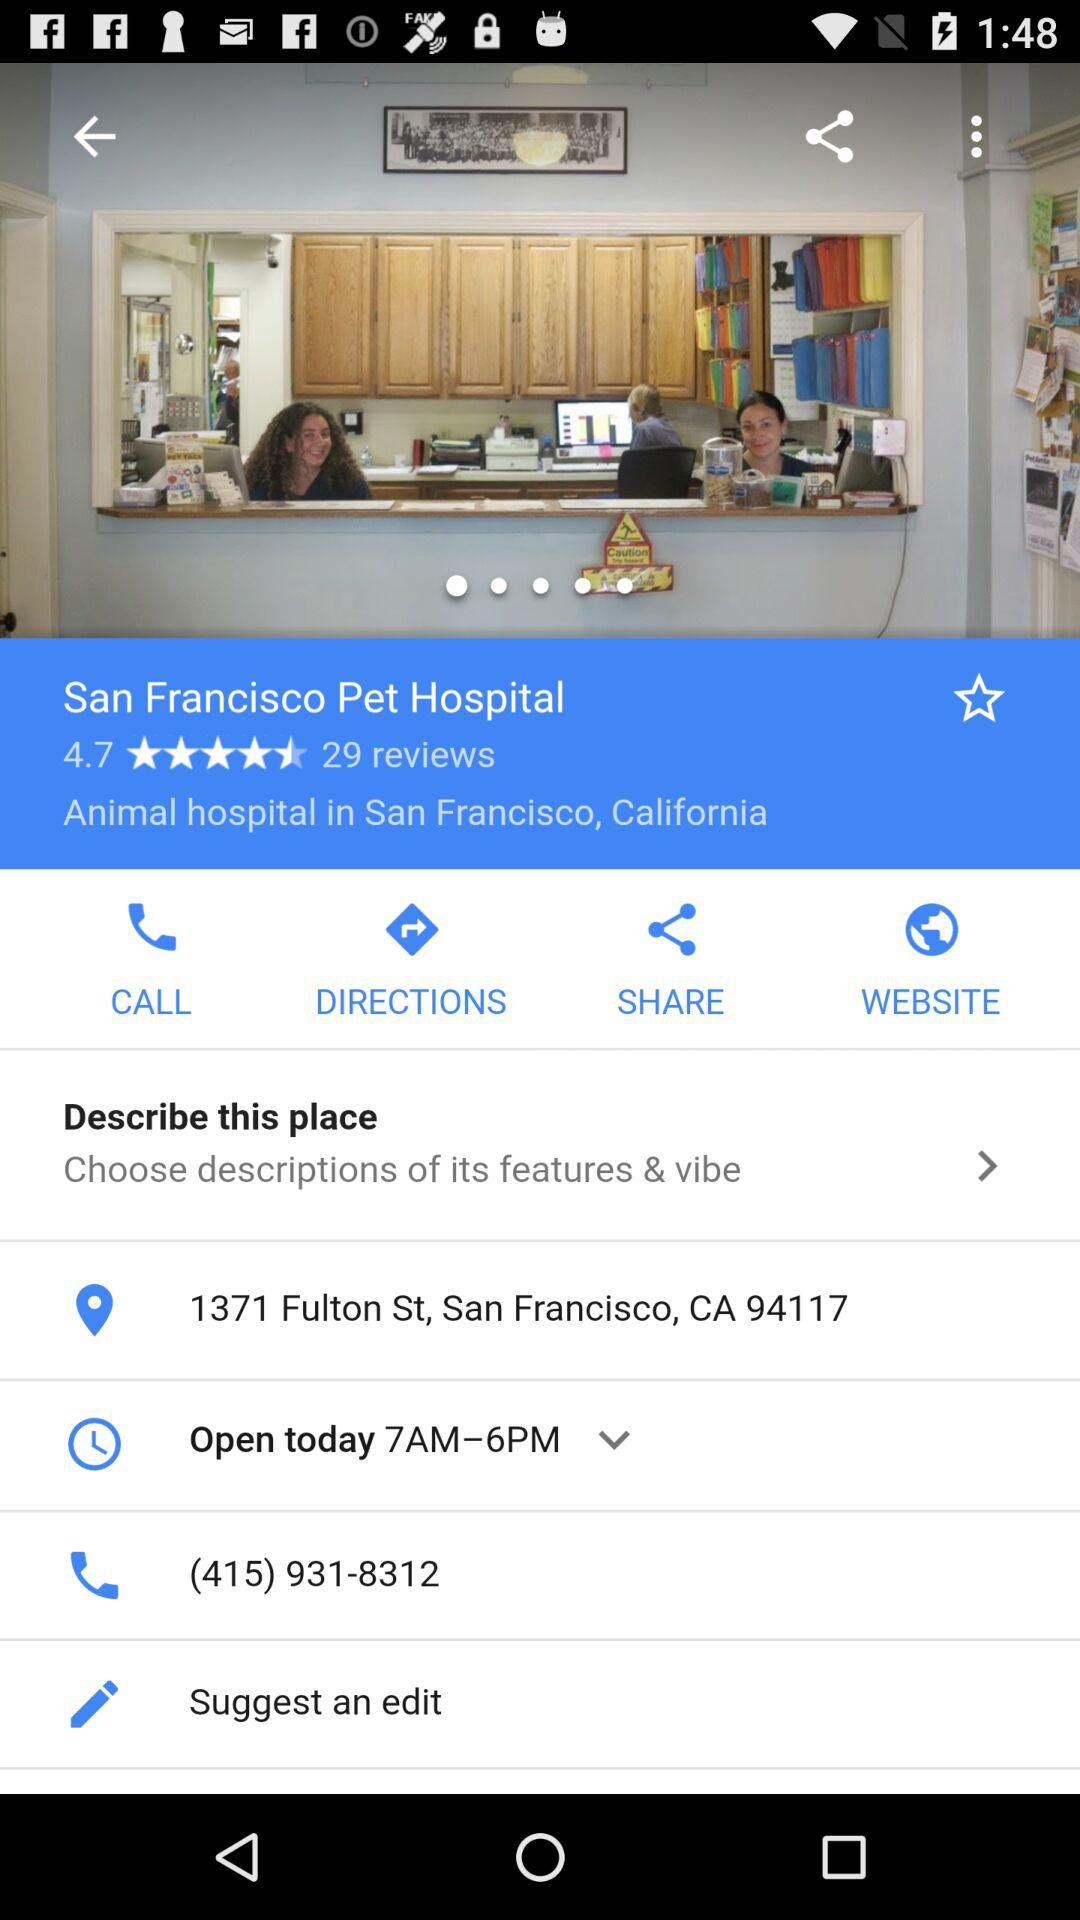What is the address? The address is 1371 Fulton St, San Francisco, CA 94117. 